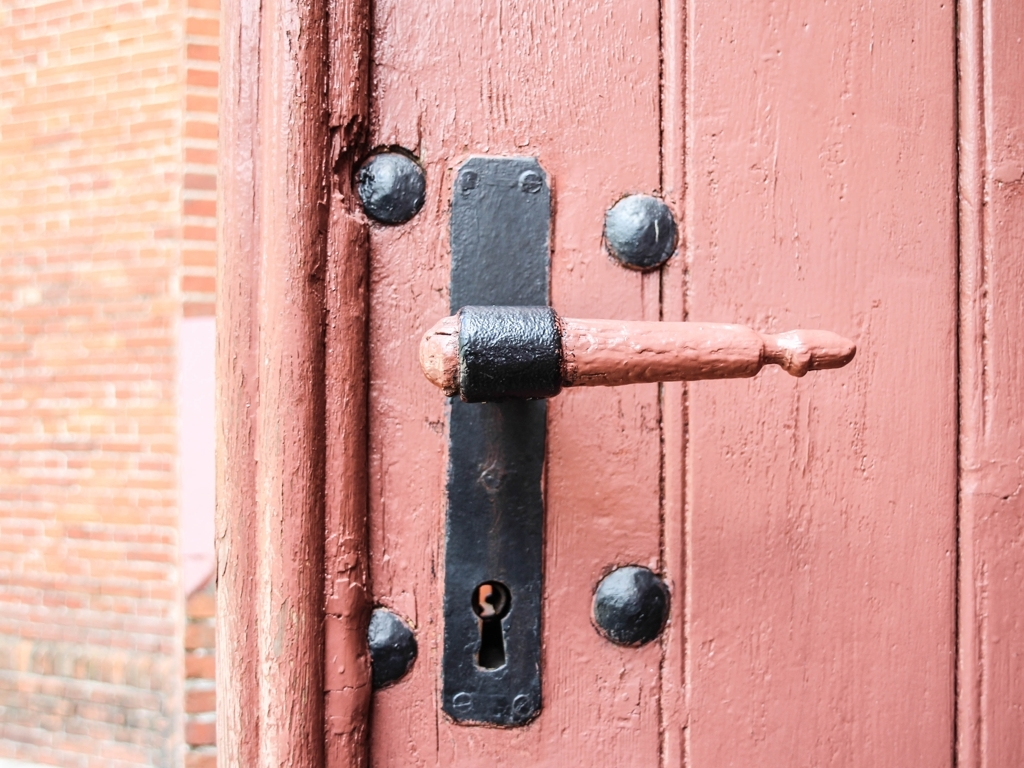Is this image well-lit? The lighting in this image is moderate, highlighting the details of the door handle and its texture while casting a slight shadow that emphasizes the contours and rustic characteristics of the door. 